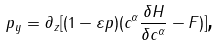Convert formula to latex. <formula><loc_0><loc_0><loc_500><loc_500>p _ { y } = \partial _ { z } [ ( 1 - \varepsilon p ) ( c ^ { \alpha } \frac { \delta H } { \delta c ^ { \alpha } } - F ) ] \text {,}</formula> 